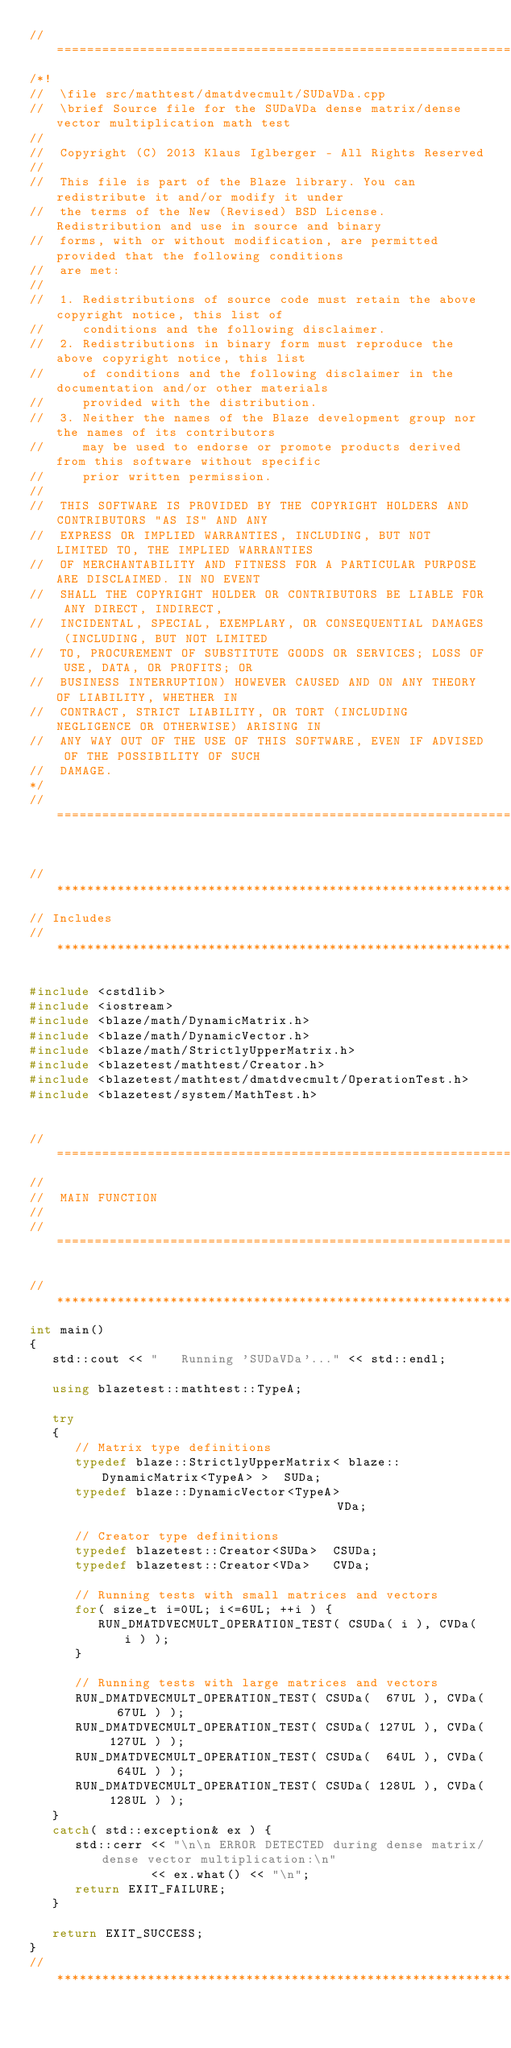<code> <loc_0><loc_0><loc_500><loc_500><_C++_>//=================================================================================================
/*!
//  \file src/mathtest/dmatdvecmult/SUDaVDa.cpp
//  \brief Source file for the SUDaVDa dense matrix/dense vector multiplication math test
//
//  Copyright (C) 2013 Klaus Iglberger - All Rights Reserved
//
//  This file is part of the Blaze library. You can redistribute it and/or modify it under
//  the terms of the New (Revised) BSD License. Redistribution and use in source and binary
//  forms, with or without modification, are permitted provided that the following conditions
//  are met:
//
//  1. Redistributions of source code must retain the above copyright notice, this list of
//     conditions and the following disclaimer.
//  2. Redistributions in binary form must reproduce the above copyright notice, this list
//     of conditions and the following disclaimer in the documentation and/or other materials
//     provided with the distribution.
//  3. Neither the names of the Blaze development group nor the names of its contributors
//     may be used to endorse or promote products derived from this software without specific
//     prior written permission.
//
//  THIS SOFTWARE IS PROVIDED BY THE COPYRIGHT HOLDERS AND CONTRIBUTORS "AS IS" AND ANY
//  EXPRESS OR IMPLIED WARRANTIES, INCLUDING, BUT NOT LIMITED TO, THE IMPLIED WARRANTIES
//  OF MERCHANTABILITY AND FITNESS FOR A PARTICULAR PURPOSE ARE DISCLAIMED. IN NO EVENT
//  SHALL THE COPYRIGHT HOLDER OR CONTRIBUTORS BE LIABLE FOR ANY DIRECT, INDIRECT,
//  INCIDENTAL, SPECIAL, EXEMPLARY, OR CONSEQUENTIAL DAMAGES (INCLUDING, BUT NOT LIMITED
//  TO, PROCUREMENT OF SUBSTITUTE GOODS OR SERVICES; LOSS OF USE, DATA, OR PROFITS; OR
//  BUSINESS INTERRUPTION) HOWEVER CAUSED AND ON ANY THEORY OF LIABILITY, WHETHER IN
//  CONTRACT, STRICT LIABILITY, OR TORT (INCLUDING NEGLIGENCE OR OTHERWISE) ARISING IN
//  ANY WAY OUT OF THE USE OF THIS SOFTWARE, EVEN IF ADVISED OF THE POSSIBILITY OF SUCH
//  DAMAGE.
*/
//=================================================================================================


//*************************************************************************************************
// Includes
//*************************************************************************************************

#include <cstdlib>
#include <iostream>
#include <blaze/math/DynamicMatrix.h>
#include <blaze/math/DynamicVector.h>
#include <blaze/math/StrictlyUpperMatrix.h>
#include <blazetest/mathtest/Creator.h>
#include <blazetest/mathtest/dmatdvecmult/OperationTest.h>
#include <blazetest/system/MathTest.h>


//=================================================================================================
//
//  MAIN FUNCTION
//
//=================================================================================================

//*************************************************************************************************
int main()
{
   std::cout << "   Running 'SUDaVDa'..." << std::endl;

   using blazetest::mathtest::TypeA;

   try
   {
      // Matrix type definitions
      typedef blaze::StrictlyUpperMatrix< blaze::DynamicMatrix<TypeA> >  SUDa;
      typedef blaze::DynamicVector<TypeA>                                VDa;

      // Creator type definitions
      typedef blazetest::Creator<SUDa>  CSUDa;
      typedef blazetest::Creator<VDa>   CVDa;

      // Running tests with small matrices and vectors
      for( size_t i=0UL; i<=6UL; ++i ) {
         RUN_DMATDVECMULT_OPERATION_TEST( CSUDa( i ), CVDa( i ) );
      }

      // Running tests with large matrices and vectors
      RUN_DMATDVECMULT_OPERATION_TEST( CSUDa(  67UL ), CVDa(  67UL ) );
      RUN_DMATDVECMULT_OPERATION_TEST( CSUDa( 127UL ), CVDa( 127UL ) );
      RUN_DMATDVECMULT_OPERATION_TEST( CSUDa(  64UL ), CVDa(  64UL ) );
      RUN_DMATDVECMULT_OPERATION_TEST( CSUDa( 128UL ), CVDa( 128UL ) );
   }
   catch( std::exception& ex ) {
      std::cerr << "\n\n ERROR DETECTED during dense matrix/dense vector multiplication:\n"
                << ex.what() << "\n";
      return EXIT_FAILURE;
   }

   return EXIT_SUCCESS;
}
//*************************************************************************************************
</code> 